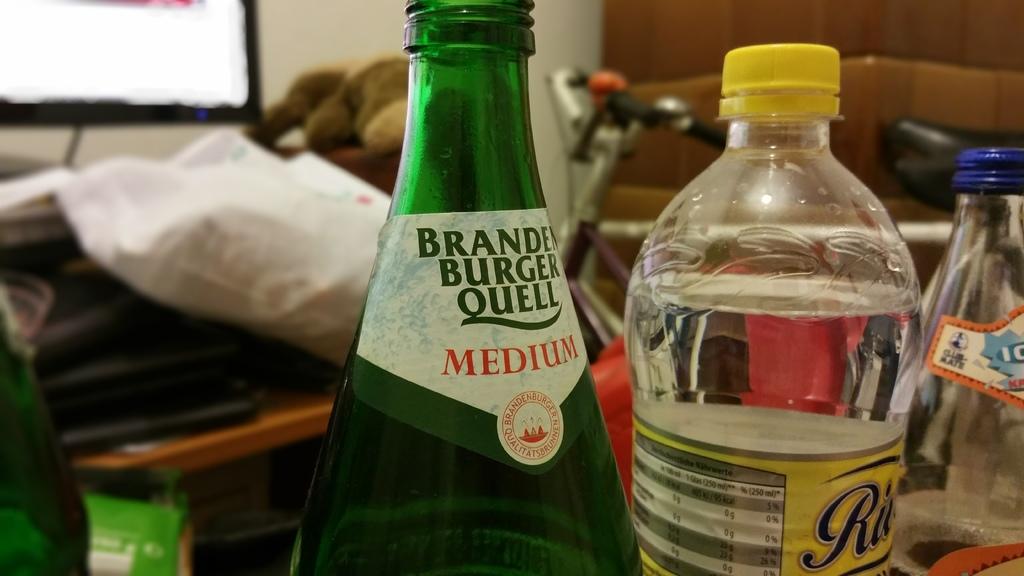Is that a medium?
Provide a short and direct response. Yes. What is the brand of beer in the green bottle?
Ensure brevity in your answer.  Branden burger quell. 